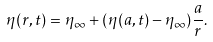<formula> <loc_0><loc_0><loc_500><loc_500>\eta ( r , t ) = \eta _ { \infty } + ( \eta ( a , t ) - \eta _ { \infty } ) \frac { a } { r } .</formula> 